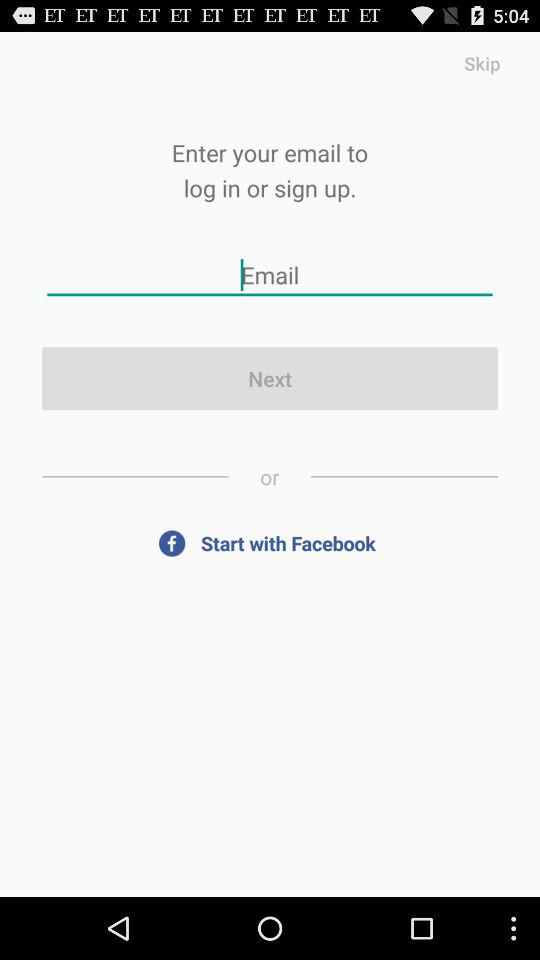What is the requirement for logging in or signing up? For logging in or signing up, email is required. 